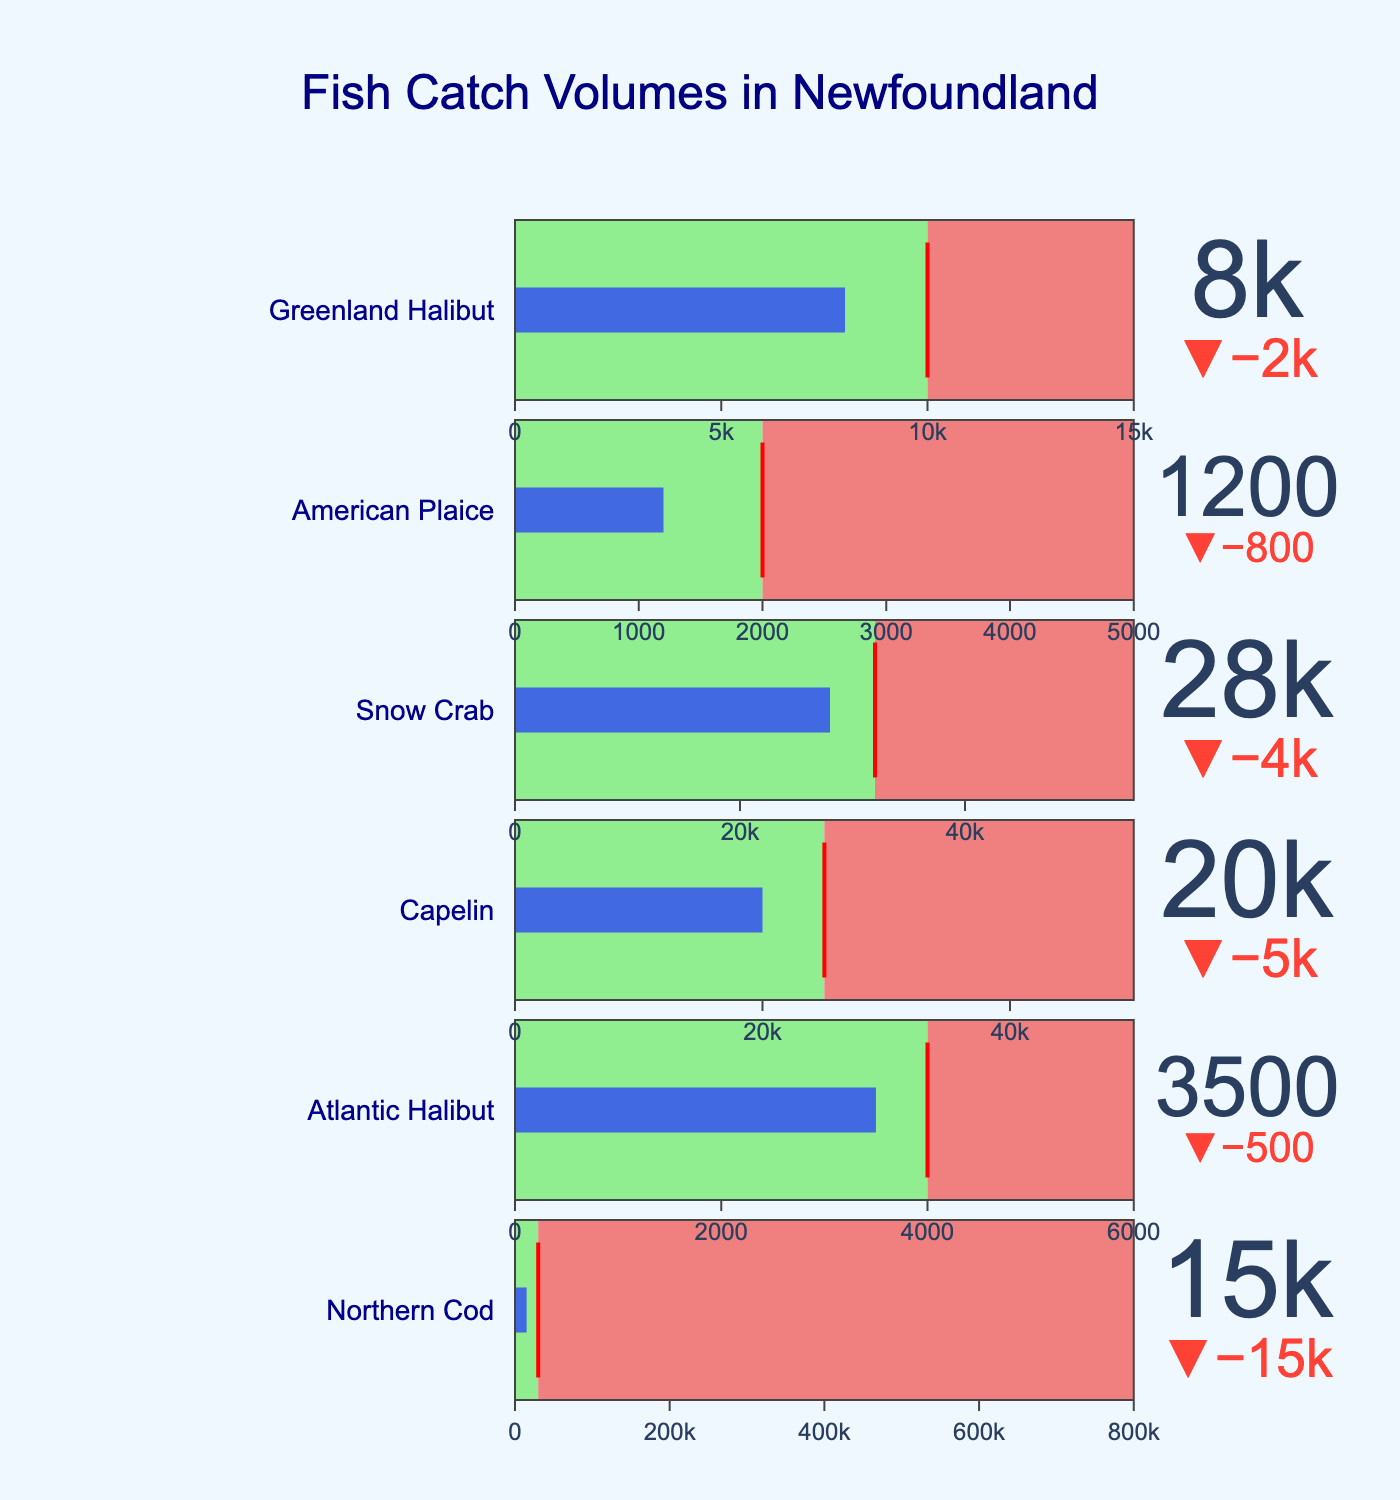How many fish species are listed in the figure? Count the number of different fish species listed in the chart. There are 6 species: Northern Cod, Atlantic Halibut, Capelin, Snow Crab, American Plaice, and Greenland Halibut.
Answer: 6 Which fish species has the highest sustainable quota? Compare the sustainable quota values for each fish species. Snow Crab has the highest sustainable quota with 32000 tonnes.
Answer: Snow Crab Is the actual catch of Northern Cod less than its sustainable quota? Compare the actual catch (15000 tonnes) to the sustainable quota (30000 tonnes) for Northern Cod. Yes, the actual catch of Northern Cod is less than its sustainable quota.
Answer: Yes What is the difference between the actual catch and the sustainable quota for American Plaice? Calculate the difference: Sustainable Quota (2000 tonnes) - Actual Catch (1200 tonnes) = 800 tonnes.
Answer: 800 tonnes Which species' actual catch is closest to its sustainable quota? Determine the absolute differences between the actual catch and sustainable quota for each species. For Atlantic Halibut, the difference is only 500 tonnes, which is the smallest difference among all species.
Answer: Atlantic Halibut What is the average historical peak of all fish species? Add up the historical peaks of all fish species: 800000 + 6000 + 50000 + 55000 + 5000 + 15000 = 931000 tonnes. Divide by the number of species: 931000 / 6 = 155166.67 tonnes.
Answer: 155166.67 tonnes Is the actual catch of Greenland Halibut in the same range as its sustainable quota in the chart? Check the placement of Greenland Halibut’s actual catch on the bullet chart against its sustainable quota. The actual catch (8000 tonnes) falls within the range (0 to 10000 tonnes) indicated by the light green color.
Answer: Yes Which fish species has the greatest difference between its historical peak and sustainable quota? Calculate the differences for each species: 
Northern Cod: 800000 - 30000 = 770000
Atlantic Halibut: 6000 - 4000 = 2000
Capelin: 50000 - 25000 = 25000
Snow Crab: 55000 - 32000 = 23000
American Plaice: 5000 - 2000 = 3000
Greenland Halibut: 15000 - 10000 = 5000
Northern Cod has the greatest difference of 770000 tonnes.
Answer: Northern Cod Which fish species has the actual catch exceeding the sustainable quota? Compare the actual catch to the sustainable quota for each species. None of the species' actual catches exceed their sustainable quotas.
Answer: None 